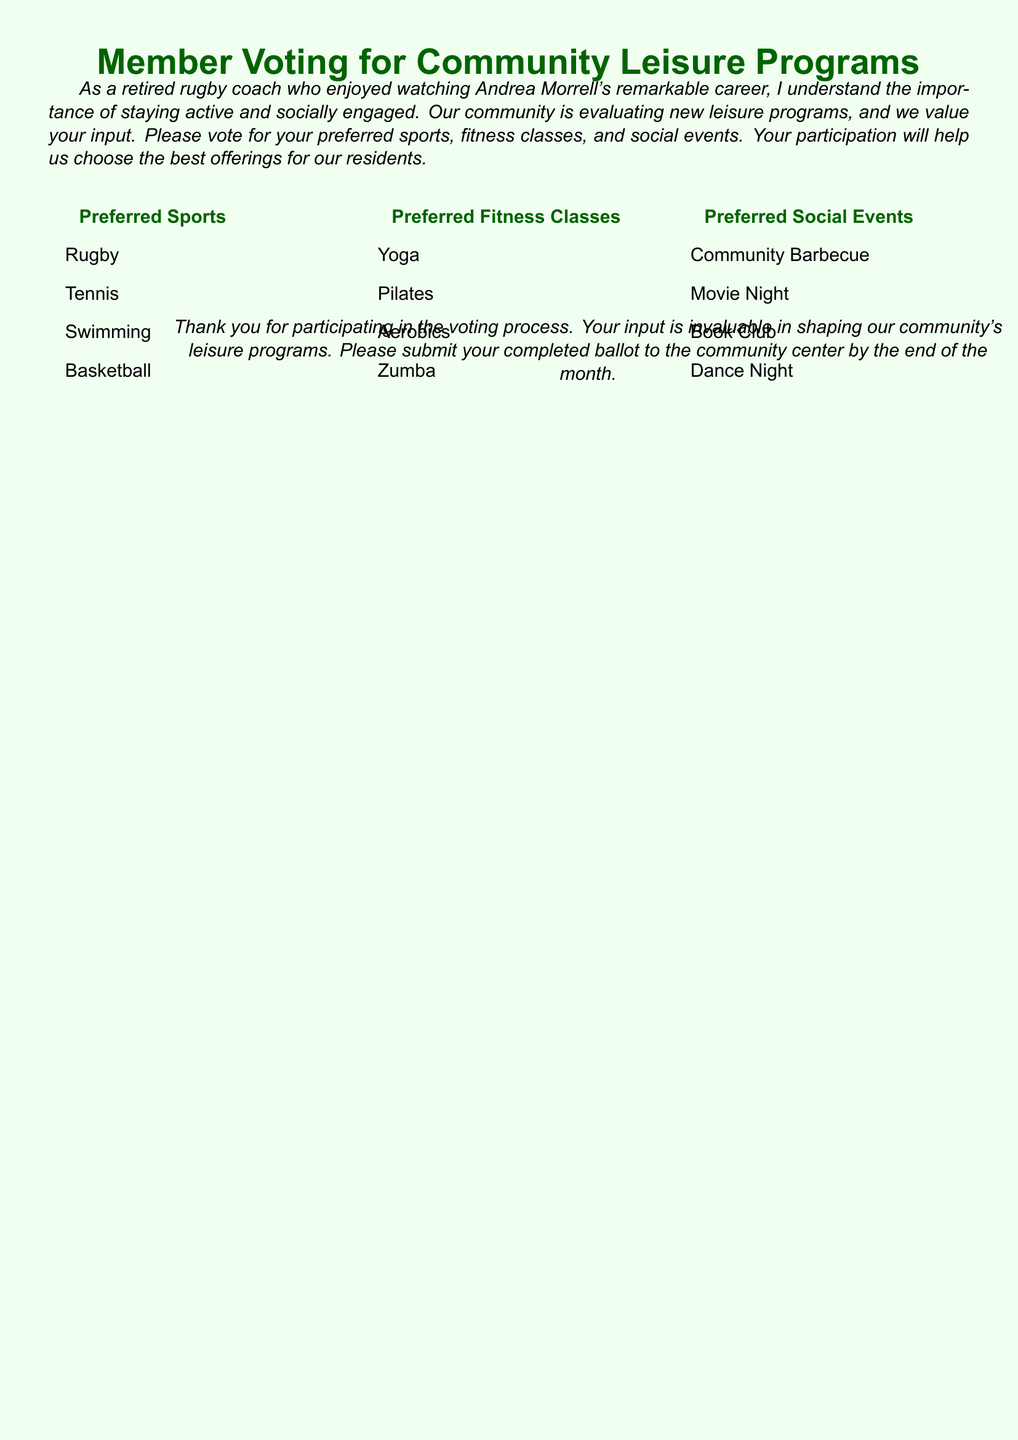What is the main purpose of this document? The document aims to gather input from residents on their preferred sports, fitness classes, and social events for community leisure programs.
Answer: Gather input How many preferred sports are listed in the ballot? There are four sports options provided in the document for residents to choose from.
Answer: Four Which social event option is mentioned first? The first social event option listed in the document is the Community Barbecue.
Answer: Community Barbecue What color is used for the headings in the document? The headings are colored in a shade defined as rugby green.
Answer: Rugby green What are the four preferred fitness classes? The document specifies four fitness class options that residents can vote for, and it lists them explicitly.
Answer: Yoga, Pilates, Aerobics, Zumba How should residents submit their completed ballot? The document instructs residents to submit their completed ballot to the community center.
Answer: Community center What is the deadline for submitting the ballot? The completed ballot must be submitted to the community center by the end of the month.
Answer: End of the month Which sport listed could be considered a team sport? Among the options presented, rugby can be identified as a team sport, distinguishing it from the others.
Answer: Rugby How is the document visually structured? The document uses a three-column layout to present the preferred sports, fitness classes, and social events clearly.
Answer: Three-column layout 